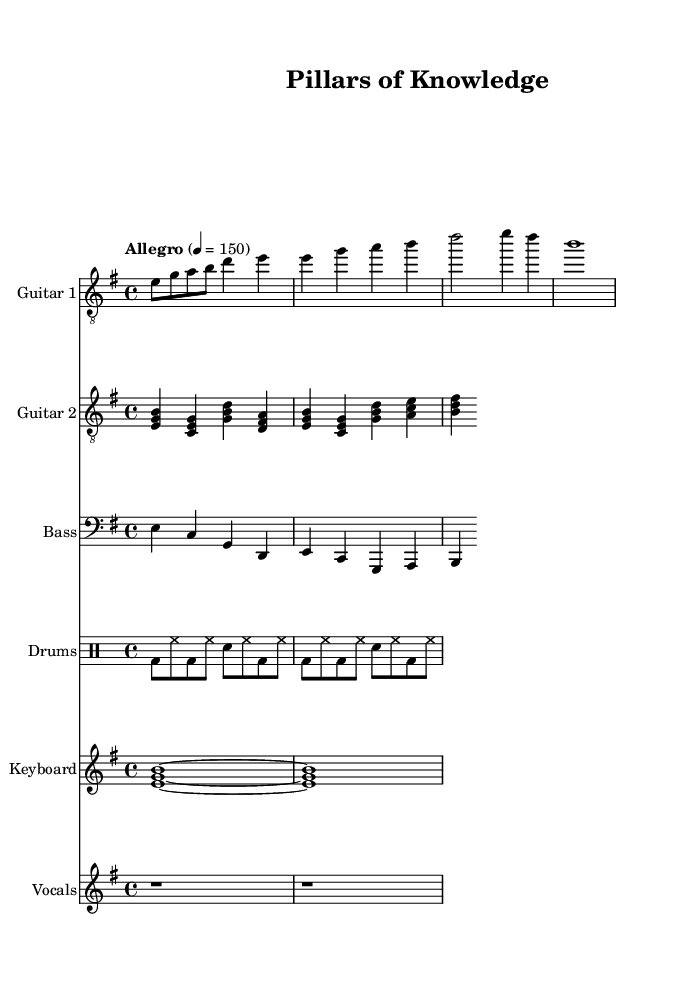What is the key signature of this music? The key signature is E minor, indicated by the presence of one sharp (F#) in the key signature section on the staff.
Answer: E minor What is the time signature of this music? The time signature displayed is 4/4, shown at the beginning of the score indicating four beats per measure and a quarter note receives one beat.
Answer: 4/4 What is the tempo marking for this piece? The tempo marking is "Allegro," which means a fast and lively tempo, and specifically indicates the speed of 150 beats per minute as denoted next to the tempo indication.
Answer: Allegro How many measures does the main riff for guitar one consist of? The main riff for guitar one contains four measures, counting each segment separated by the vertical bar lines in the musical staff.
Answer: 4 measures What is the instrument playing the chord progression for the verse and chorus? The instrument executing the chord progression is Guitar 2, displayed on its dedicated staff below Guitar 1, where the chords are indicated in the measure.
Answer: Guitar 2 What is the function of the keyboard in this composition? The keyboard serves as an orchestral element in this piece, providing a harmonic background that supports the melody, as shown by the single sustained chords.
Answer: Orchestral How are the drums structured in the pattern provided? The drums are structured with a mix of bass drums, hi-hats, and snare drums, creating a typical metal rhythm that emphasizes the beats in a straightforward pattern.
Answer: Mix of bass, hi-hats, and snare 